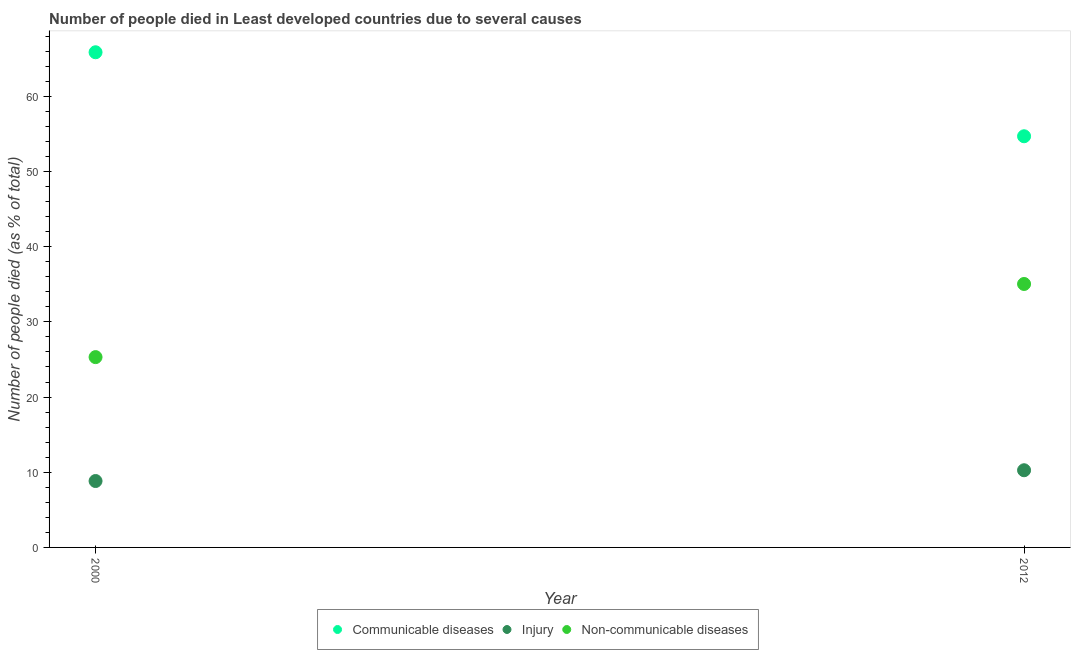What is the number of people who died of communicable diseases in 2000?
Offer a very short reply. 65.86. Across all years, what is the maximum number of people who dies of non-communicable diseases?
Make the answer very short. 35.04. Across all years, what is the minimum number of people who died of communicable diseases?
Ensure brevity in your answer.  54.69. What is the total number of people who dies of non-communicable diseases in the graph?
Make the answer very short. 60.36. What is the difference between the number of people who died of communicable diseases in 2000 and that in 2012?
Your answer should be very brief. 11.17. What is the difference between the number of people who died of injury in 2012 and the number of people who dies of non-communicable diseases in 2000?
Provide a succinct answer. -15.05. What is the average number of people who died of injury per year?
Your response must be concise. 9.55. In the year 2012, what is the difference between the number of people who died of injury and number of people who died of communicable diseases?
Provide a succinct answer. -44.43. What is the ratio of the number of people who died of injury in 2000 to that in 2012?
Make the answer very short. 0.86. Is the number of people who dies of non-communicable diseases in 2000 less than that in 2012?
Provide a short and direct response. Yes. Is it the case that in every year, the sum of the number of people who died of communicable diseases and number of people who died of injury is greater than the number of people who dies of non-communicable diseases?
Offer a terse response. Yes. Does the number of people who dies of non-communicable diseases monotonically increase over the years?
Keep it short and to the point. Yes. Is the number of people who died of injury strictly greater than the number of people who dies of non-communicable diseases over the years?
Make the answer very short. No. Is the number of people who dies of non-communicable diseases strictly less than the number of people who died of injury over the years?
Provide a short and direct response. No. How many dotlines are there?
Ensure brevity in your answer.  3. What is the difference between two consecutive major ticks on the Y-axis?
Give a very brief answer. 10. Does the graph contain any zero values?
Make the answer very short. No. What is the title of the graph?
Provide a succinct answer. Number of people died in Least developed countries due to several causes. Does "Social Insurance" appear as one of the legend labels in the graph?
Give a very brief answer. No. What is the label or title of the X-axis?
Make the answer very short. Year. What is the label or title of the Y-axis?
Your answer should be compact. Number of people died (as % of total). What is the Number of people died (as % of total) of Communicable diseases in 2000?
Provide a succinct answer. 65.86. What is the Number of people died (as % of total) of Injury in 2000?
Make the answer very short. 8.83. What is the Number of people died (as % of total) in Non-communicable diseases in 2000?
Your answer should be very brief. 25.31. What is the Number of people died (as % of total) in Communicable diseases in 2012?
Provide a succinct answer. 54.69. What is the Number of people died (as % of total) of Injury in 2012?
Provide a succinct answer. 10.27. What is the Number of people died (as % of total) in Non-communicable diseases in 2012?
Give a very brief answer. 35.04. Across all years, what is the maximum Number of people died (as % of total) in Communicable diseases?
Your answer should be very brief. 65.86. Across all years, what is the maximum Number of people died (as % of total) of Injury?
Your answer should be very brief. 10.27. Across all years, what is the maximum Number of people died (as % of total) in Non-communicable diseases?
Ensure brevity in your answer.  35.04. Across all years, what is the minimum Number of people died (as % of total) in Communicable diseases?
Your response must be concise. 54.69. Across all years, what is the minimum Number of people died (as % of total) in Injury?
Your answer should be very brief. 8.83. Across all years, what is the minimum Number of people died (as % of total) of Non-communicable diseases?
Your response must be concise. 25.31. What is the total Number of people died (as % of total) of Communicable diseases in the graph?
Make the answer very short. 120.56. What is the total Number of people died (as % of total) in Injury in the graph?
Provide a succinct answer. 19.1. What is the total Number of people died (as % of total) in Non-communicable diseases in the graph?
Provide a short and direct response. 60.36. What is the difference between the Number of people died (as % of total) in Communicable diseases in 2000 and that in 2012?
Offer a very short reply. 11.17. What is the difference between the Number of people died (as % of total) in Injury in 2000 and that in 2012?
Your response must be concise. -1.43. What is the difference between the Number of people died (as % of total) of Non-communicable diseases in 2000 and that in 2012?
Offer a very short reply. -9.73. What is the difference between the Number of people died (as % of total) in Communicable diseases in 2000 and the Number of people died (as % of total) in Injury in 2012?
Provide a succinct answer. 55.6. What is the difference between the Number of people died (as % of total) in Communicable diseases in 2000 and the Number of people died (as % of total) in Non-communicable diseases in 2012?
Your response must be concise. 30.82. What is the difference between the Number of people died (as % of total) of Injury in 2000 and the Number of people died (as % of total) of Non-communicable diseases in 2012?
Ensure brevity in your answer.  -26.21. What is the average Number of people died (as % of total) in Communicable diseases per year?
Your answer should be compact. 60.28. What is the average Number of people died (as % of total) in Injury per year?
Make the answer very short. 9.55. What is the average Number of people died (as % of total) of Non-communicable diseases per year?
Provide a short and direct response. 30.18. In the year 2000, what is the difference between the Number of people died (as % of total) of Communicable diseases and Number of people died (as % of total) of Injury?
Ensure brevity in your answer.  57.03. In the year 2000, what is the difference between the Number of people died (as % of total) of Communicable diseases and Number of people died (as % of total) of Non-communicable diseases?
Your answer should be compact. 40.55. In the year 2000, what is the difference between the Number of people died (as % of total) in Injury and Number of people died (as % of total) in Non-communicable diseases?
Provide a succinct answer. -16.48. In the year 2012, what is the difference between the Number of people died (as % of total) in Communicable diseases and Number of people died (as % of total) in Injury?
Make the answer very short. 44.43. In the year 2012, what is the difference between the Number of people died (as % of total) in Communicable diseases and Number of people died (as % of total) in Non-communicable diseases?
Offer a terse response. 19.65. In the year 2012, what is the difference between the Number of people died (as % of total) of Injury and Number of people died (as % of total) of Non-communicable diseases?
Your answer should be very brief. -24.78. What is the ratio of the Number of people died (as % of total) of Communicable diseases in 2000 to that in 2012?
Offer a terse response. 1.2. What is the ratio of the Number of people died (as % of total) in Injury in 2000 to that in 2012?
Offer a very short reply. 0.86. What is the ratio of the Number of people died (as % of total) of Non-communicable diseases in 2000 to that in 2012?
Give a very brief answer. 0.72. What is the difference between the highest and the second highest Number of people died (as % of total) of Communicable diseases?
Make the answer very short. 11.17. What is the difference between the highest and the second highest Number of people died (as % of total) of Injury?
Make the answer very short. 1.43. What is the difference between the highest and the second highest Number of people died (as % of total) of Non-communicable diseases?
Your response must be concise. 9.73. What is the difference between the highest and the lowest Number of people died (as % of total) in Communicable diseases?
Ensure brevity in your answer.  11.17. What is the difference between the highest and the lowest Number of people died (as % of total) of Injury?
Offer a terse response. 1.43. What is the difference between the highest and the lowest Number of people died (as % of total) of Non-communicable diseases?
Your answer should be very brief. 9.73. 